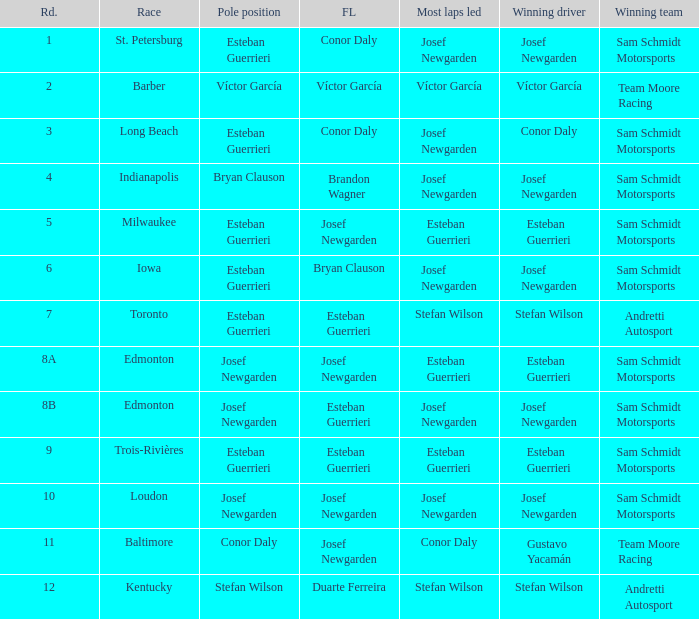Who had the fastest lap(s) when josef newgarden led the most laps at edmonton? Esteban Guerrieri. 